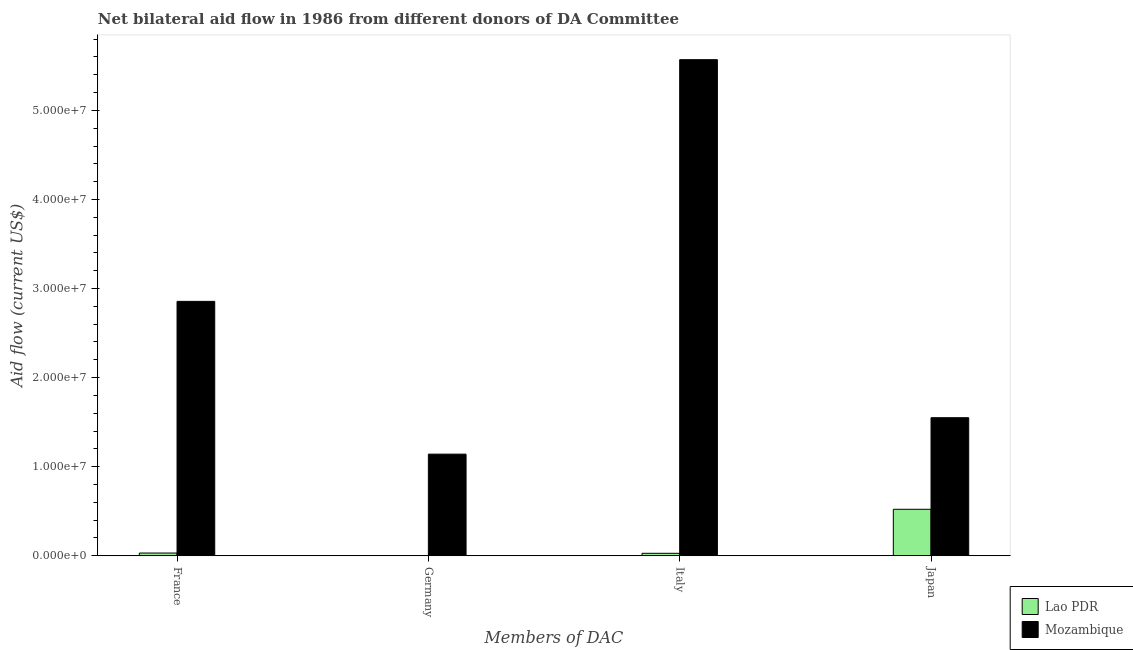How many bars are there on the 4th tick from the left?
Make the answer very short. 2. How many bars are there on the 4th tick from the right?
Ensure brevity in your answer.  2. What is the amount of aid given by italy in Mozambique?
Offer a very short reply. 5.57e+07. Across all countries, what is the maximum amount of aid given by france?
Provide a short and direct response. 2.86e+07. Across all countries, what is the minimum amount of aid given by france?
Your response must be concise. 3.10e+05. In which country was the amount of aid given by italy maximum?
Offer a terse response. Mozambique. What is the total amount of aid given by germany in the graph?
Provide a short and direct response. 1.14e+07. What is the difference between the amount of aid given by france in Mozambique and that in Lao PDR?
Provide a succinct answer. 2.82e+07. What is the difference between the amount of aid given by france in Mozambique and the amount of aid given by japan in Lao PDR?
Ensure brevity in your answer.  2.33e+07. What is the average amount of aid given by japan per country?
Your answer should be very brief. 1.04e+07. What is the difference between the amount of aid given by france and amount of aid given by japan in Mozambique?
Your answer should be compact. 1.31e+07. In how many countries, is the amount of aid given by france greater than 36000000 US$?
Your response must be concise. 0. What is the ratio of the amount of aid given by japan in Mozambique to that in Lao PDR?
Provide a short and direct response. 2.97. Is the amount of aid given by japan in Lao PDR less than that in Mozambique?
Offer a terse response. Yes. Is the difference between the amount of aid given by france in Mozambique and Lao PDR greater than the difference between the amount of aid given by italy in Mozambique and Lao PDR?
Ensure brevity in your answer.  No. What is the difference between the highest and the second highest amount of aid given by italy?
Your answer should be compact. 5.54e+07. What is the difference between the highest and the lowest amount of aid given by germany?
Keep it short and to the point. 1.14e+07. In how many countries, is the amount of aid given by germany greater than the average amount of aid given by germany taken over all countries?
Offer a terse response. 1. Is the sum of the amount of aid given by france in Mozambique and Lao PDR greater than the maximum amount of aid given by germany across all countries?
Offer a very short reply. Yes. Is it the case that in every country, the sum of the amount of aid given by france and amount of aid given by japan is greater than the sum of amount of aid given by italy and amount of aid given by germany?
Give a very brief answer. No. Is it the case that in every country, the sum of the amount of aid given by france and amount of aid given by germany is greater than the amount of aid given by italy?
Offer a terse response. No. How many countries are there in the graph?
Provide a short and direct response. 2. Are the values on the major ticks of Y-axis written in scientific E-notation?
Your answer should be very brief. Yes. Does the graph contain any zero values?
Ensure brevity in your answer.  Yes. Does the graph contain grids?
Your answer should be very brief. No. Where does the legend appear in the graph?
Offer a terse response. Bottom right. How are the legend labels stacked?
Provide a succinct answer. Vertical. What is the title of the graph?
Give a very brief answer. Net bilateral aid flow in 1986 from different donors of DA Committee. What is the label or title of the X-axis?
Provide a short and direct response. Members of DAC. What is the Aid flow (current US$) in Lao PDR in France?
Offer a very short reply. 3.10e+05. What is the Aid flow (current US$) in Mozambique in France?
Your answer should be compact. 2.86e+07. What is the Aid flow (current US$) in Mozambique in Germany?
Provide a short and direct response. 1.14e+07. What is the Aid flow (current US$) of Lao PDR in Italy?
Make the answer very short. 2.80e+05. What is the Aid flow (current US$) of Mozambique in Italy?
Make the answer very short. 5.57e+07. What is the Aid flow (current US$) of Lao PDR in Japan?
Provide a short and direct response. 5.22e+06. What is the Aid flow (current US$) in Mozambique in Japan?
Make the answer very short. 1.55e+07. Across all Members of DAC, what is the maximum Aid flow (current US$) in Lao PDR?
Provide a succinct answer. 5.22e+06. Across all Members of DAC, what is the maximum Aid flow (current US$) of Mozambique?
Offer a terse response. 5.57e+07. Across all Members of DAC, what is the minimum Aid flow (current US$) of Mozambique?
Your answer should be compact. 1.14e+07. What is the total Aid flow (current US$) of Lao PDR in the graph?
Offer a terse response. 5.81e+06. What is the total Aid flow (current US$) in Mozambique in the graph?
Your response must be concise. 1.11e+08. What is the difference between the Aid flow (current US$) of Mozambique in France and that in Germany?
Ensure brevity in your answer.  1.72e+07. What is the difference between the Aid flow (current US$) in Mozambique in France and that in Italy?
Make the answer very short. -2.71e+07. What is the difference between the Aid flow (current US$) in Lao PDR in France and that in Japan?
Make the answer very short. -4.91e+06. What is the difference between the Aid flow (current US$) of Mozambique in France and that in Japan?
Offer a very short reply. 1.31e+07. What is the difference between the Aid flow (current US$) of Mozambique in Germany and that in Italy?
Offer a very short reply. -4.43e+07. What is the difference between the Aid flow (current US$) in Mozambique in Germany and that in Japan?
Keep it short and to the point. -4.09e+06. What is the difference between the Aid flow (current US$) of Lao PDR in Italy and that in Japan?
Provide a succinct answer. -4.94e+06. What is the difference between the Aid flow (current US$) in Mozambique in Italy and that in Japan?
Provide a succinct answer. 4.02e+07. What is the difference between the Aid flow (current US$) of Lao PDR in France and the Aid flow (current US$) of Mozambique in Germany?
Offer a terse response. -1.11e+07. What is the difference between the Aid flow (current US$) in Lao PDR in France and the Aid flow (current US$) in Mozambique in Italy?
Give a very brief answer. -5.54e+07. What is the difference between the Aid flow (current US$) of Lao PDR in France and the Aid flow (current US$) of Mozambique in Japan?
Ensure brevity in your answer.  -1.52e+07. What is the difference between the Aid flow (current US$) of Lao PDR in Italy and the Aid flow (current US$) of Mozambique in Japan?
Keep it short and to the point. -1.52e+07. What is the average Aid flow (current US$) of Lao PDR per Members of DAC?
Offer a very short reply. 1.45e+06. What is the average Aid flow (current US$) in Mozambique per Members of DAC?
Your answer should be very brief. 2.78e+07. What is the difference between the Aid flow (current US$) in Lao PDR and Aid flow (current US$) in Mozambique in France?
Your answer should be very brief. -2.82e+07. What is the difference between the Aid flow (current US$) in Lao PDR and Aid flow (current US$) in Mozambique in Italy?
Offer a very short reply. -5.54e+07. What is the difference between the Aid flow (current US$) of Lao PDR and Aid flow (current US$) of Mozambique in Japan?
Your answer should be very brief. -1.03e+07. What is the ratio of the Aid flow (current US$) of Mozambique in France to that in Germany?
Keep it short and to the point. 2.5. What is the ratio of the Aid flow (current US$) in Lao PDR in France to that in Italy?
Provide a short and direct response. 1.11. What is the ratio of the Aid flow (current US$) in Mozambique in France to that in Italy?
Offer a terse response. 0.51. What is the ratio of the Aid flow (current US$) in Lao PDR in France to that in Japan?
Provide a succinct answer. 0.06. What is the ratio of the Aid flow (current US$) in Mozambique in France to that in Japan?
Your answer should be very brief. 1.84. What is the ratio of the Aid flow (current US$) in Mozambique in Germany to that in Italy?
Provide a short and direct response. 0.2. What is the ratio of the Aid flow (current US$) in Mozambique in Germany to that in Japan?
Your response must be concise. 0.74. What is the ratio of the Aid flow (current US$) in Lao PDR in Italy to that in Japan?
Offer a very short reply. 0.05. What is the ratio of the Aid flow (current US$) of Mozambique in Italy to that in Japan?
Keep it short and to the point. 3.59. What is the difference between the highest and the second highest Aid flow (current US$) in Lao PDR?
Your answer should be compact. 4.91e+06. What is the difference between the highest and the second highest Aid flow (current US$) of Mozambique?
Your response must be concise. 2.71e+07. What is the difference between the highest and the lowest Aid flow (current US$) in Lao PDR?
Offer a very short reply. 5.22e+06. What is the difference between the highest and the lowest Aid flow (current US$) in Mozambique?
Offer a terse response. 4.43e+07. 